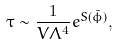<formula> <loc_0><loc_0><loc_500><loc_500>\tau \sim \frac { 1 } { V \Lambda ^ { 4 } } e ^ { S ( \bar { \phi } ) } ,</formula> 